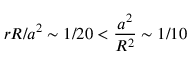Convert formula to latex. <formula><loc_0><loc_0><loc_500><loc_500>r R / a ^ { 2 } \sim 1 / 2 0 < \frac { a ^ { 2 } } { R ^ { 2 } } \sim 1 / 1 0</formula> 